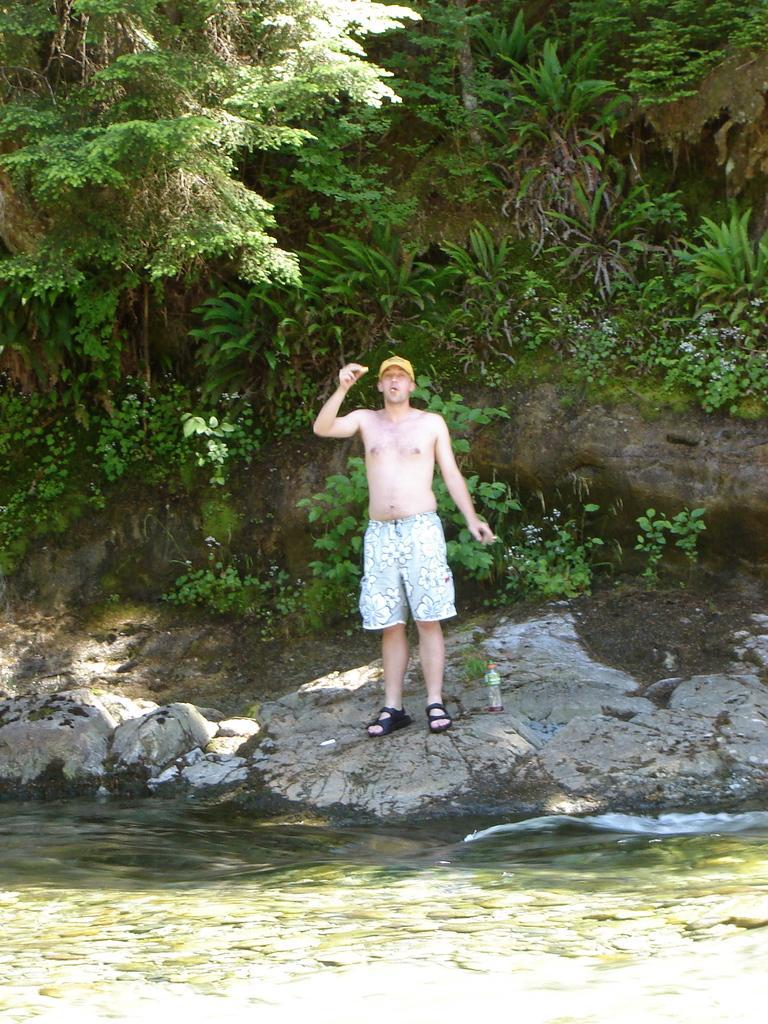Describe this image in one or two sentences. In this image I can see a person standing wearing white color short. Background I can see trees in green color, in front I can see water. 